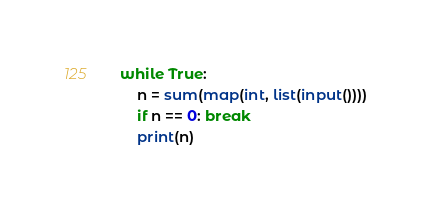Convert code to text. <code><loc_0><loc_0><loc_500><loc_500><_Python_>while True:
    n = sum(map(int, list(input())))
    if n == 0: break
    print(n)
</code> 